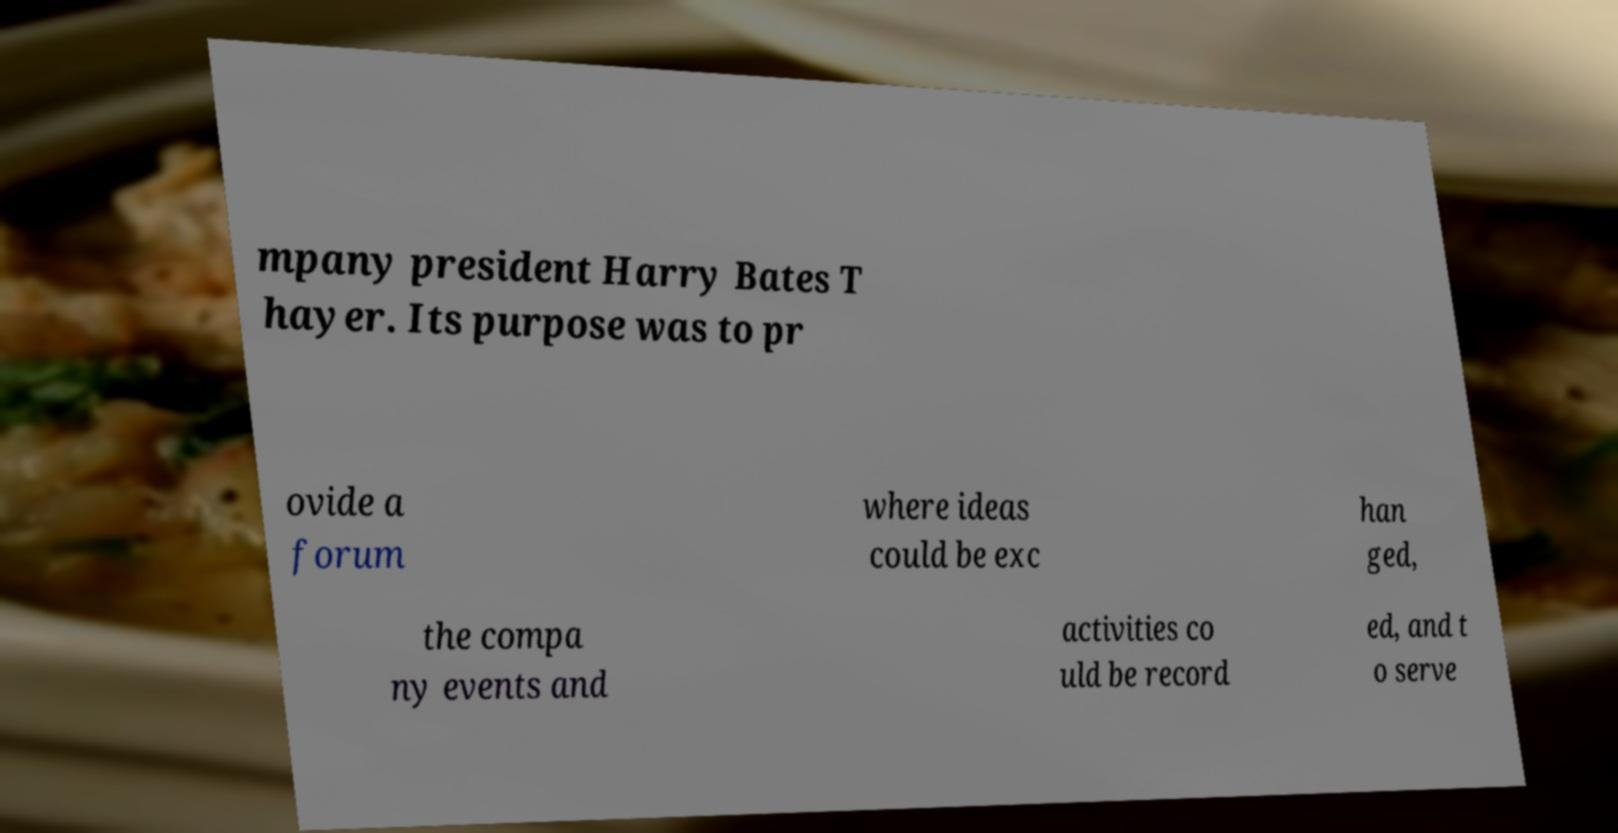Could you extract and type out the text from this image? mpany president Harry Bates T hayer. Its purpose was to pr ovide a forum where ideas could be exc han ged, the compa ny events and activities co uld be record ed, and t o serve 